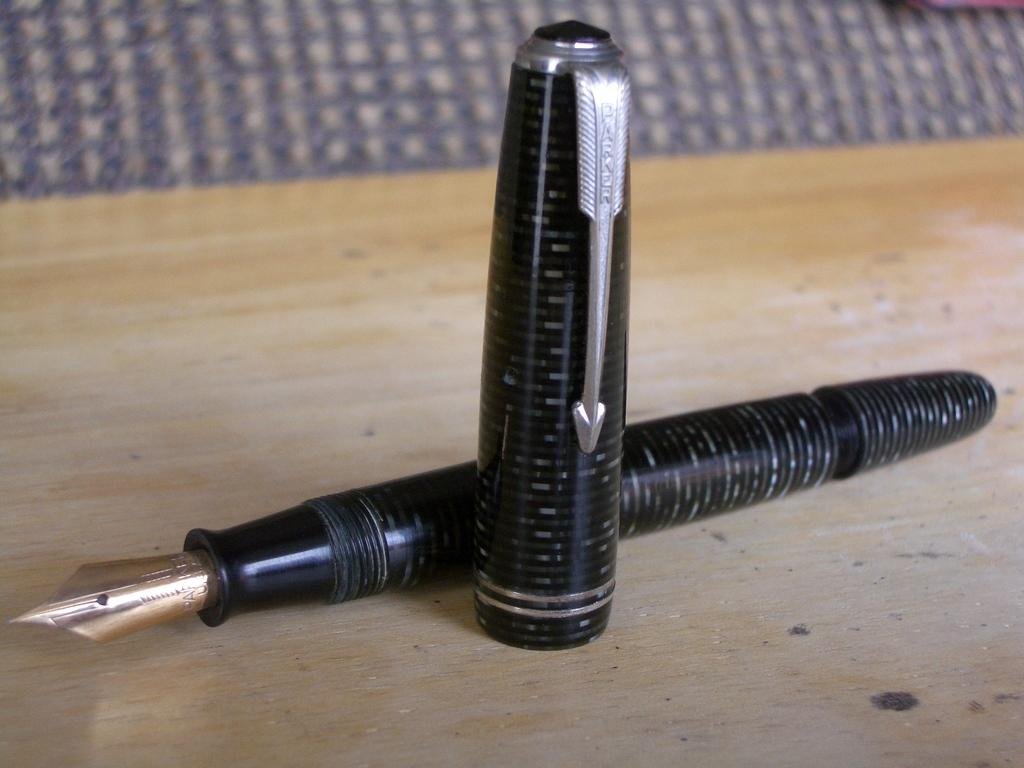What type of writing instrument is in the image? There is a black pen in the image. How is the pen positioned on the surface? The pen is placed horizontally on a surface. What else can be seen in the image related to the pen? There is a cap in the image. How is the cap positioned on the surface? The cap is placed vertically on the surface. What type of fuel is being used to power the pen in the image? There is no fuel involved in the pen's operation, as it is a writing instrument powered by ink. 